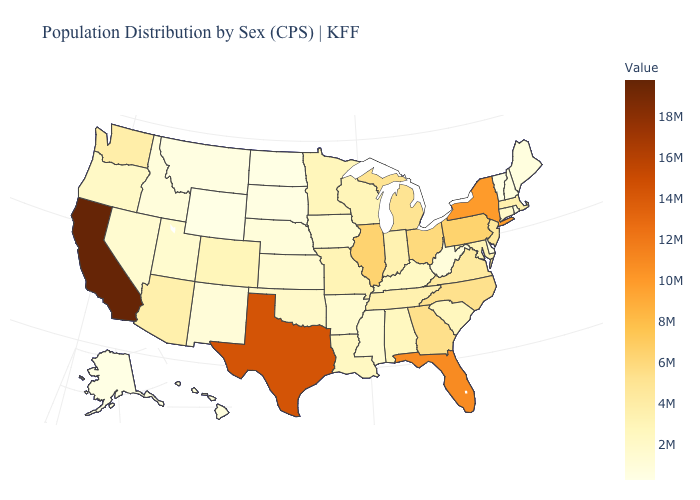Does California have the highest value in the USA?
Quick response, please. Yes. Does Ohio have the highest value in the MidWest?
Short answer required. No. Which states have the lowest value in the USA?
Keep it brief. Wyoming. Which states have the lowest value in the USA?
Give a very brief answer. Wyoming. 